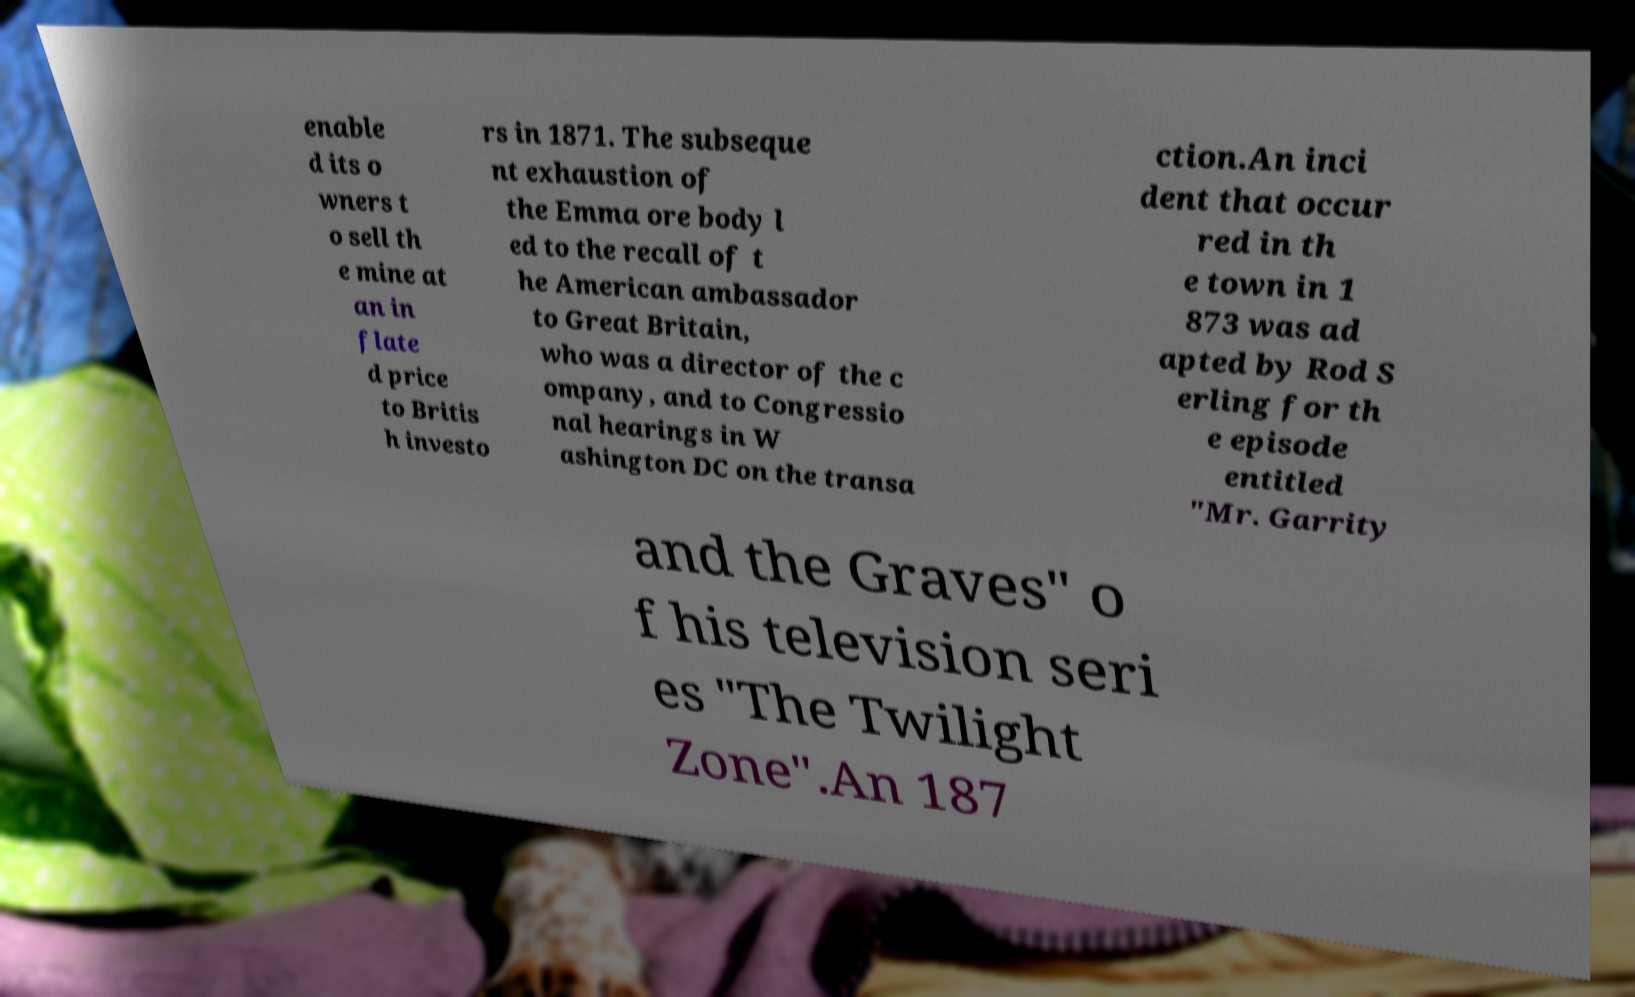Please identify and transcribe the text found in this image. enable d its o wners t o sell th e mine at an in flate d price to Britis h investo rs in 1871. The subseque nt exhaustion of the Emma ore body l ed to the recall of t he American ambassador to Great Britain, who was a director of the c ompany, and to Congressio nal hearings in W ashington DC on the transa ction.An inci dent that occur red in th e town in 1 873 was ad apted by Rod S erling for th e episode entitled "Mr. Garrity and the Graves" o f his television seri es "The Twilight Zone".An 187 